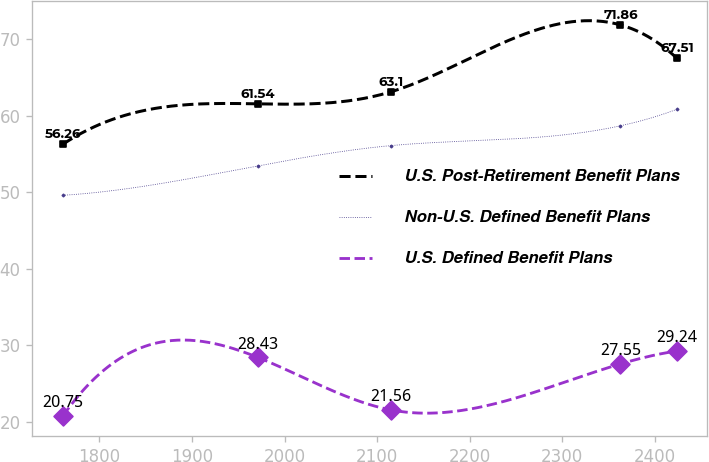Convert chart to OTSL. <chart><loc_0><loc_0><loc_500><loc_500><line_chart><ecel><fcel>U.S. Post-Retirement Benefit Plans<fcel>Non-U.S. Defined Benefit Plans<fcel>U.S. Defined Benefit Plans<nl><fcel>1760.43<fcel>56.26<fcel>49.59<fcel>20.75<nl><fcel>1970.9<fcel>61.54<fcel>53.43<fcel>28.43<nl><fcel>2114.76<fcel>63.1<fcel>56.08<fcel>21.56<nl><fcel>2362.68<fcel>71.86<fcel>58.66<fcel>27.55<nl><fcel>2423.86<fcel>67.51<fcel>60.82<fcel>29.24<nl></chart> 